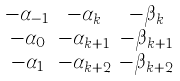<formula> <loc_0><loc_0><loc_500><loc_500>\begin{smallmatrix} - \alpha _ { - 1 } & - \alpha _ { k } & - \beta _ { k } \\ - \alpha _ { 0 } & - \alpha _ { k + 1 } & - \beta _ { k + 1 } \\ - \alpha _ { 1 } & - \alpha _ { k + 2 } & - \beta _ { k + 2 } \end{smallmatrix}</formula> 